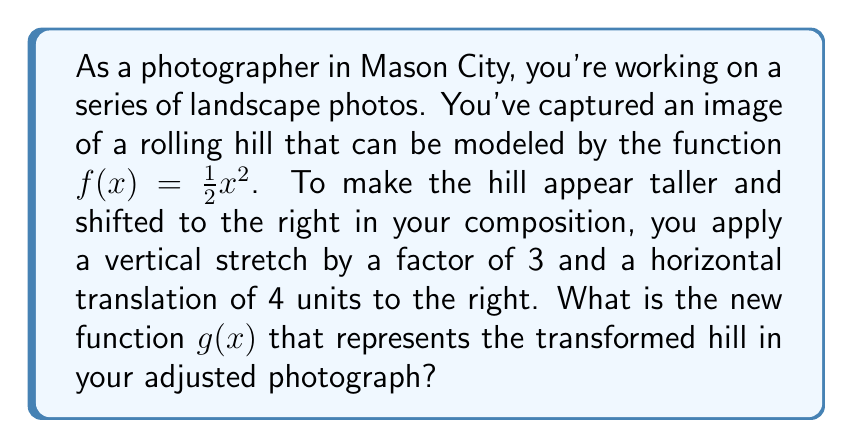Can you solve this math problem? Let's approach this step-by-step:

1) The original function is $f(x) = \frac{1}{2}x^2$

2) We need to apply two transformations:
   a) A vertical stretch by a factor of 3
   b) A horizontal translation of 4 units to the right

3) For a vertical stretch by a factor of $a$, we multiply the function by $a$:
   $3 \cdot \frac{1}{2}x^2 = \frac{3}{2}x^2$

4) For a horizontal translation of $h$ units to the right, we replace $x$ with $(x-h)$:
   $\frac{3}{2}(x-4)^2$

5) Combining these transformations, we get our new function $g(x)$:
   $g(x) = \frac{3}{2}(x-4)^2$

6) This can be expanded if needed:
   $g(x) = \frac{3}{2}(x^2 - 8x + 16)$
   $g(x) = \frac{3}{2}x^2 - 12x + 24$

However, the compact form $g(x) = \frac{3}{2}(x-4)^2$ is usually preferred as it clearly shows the transformations applied.
Answer: $g(x) = \frac{3}{2}(x-4)^2$ 